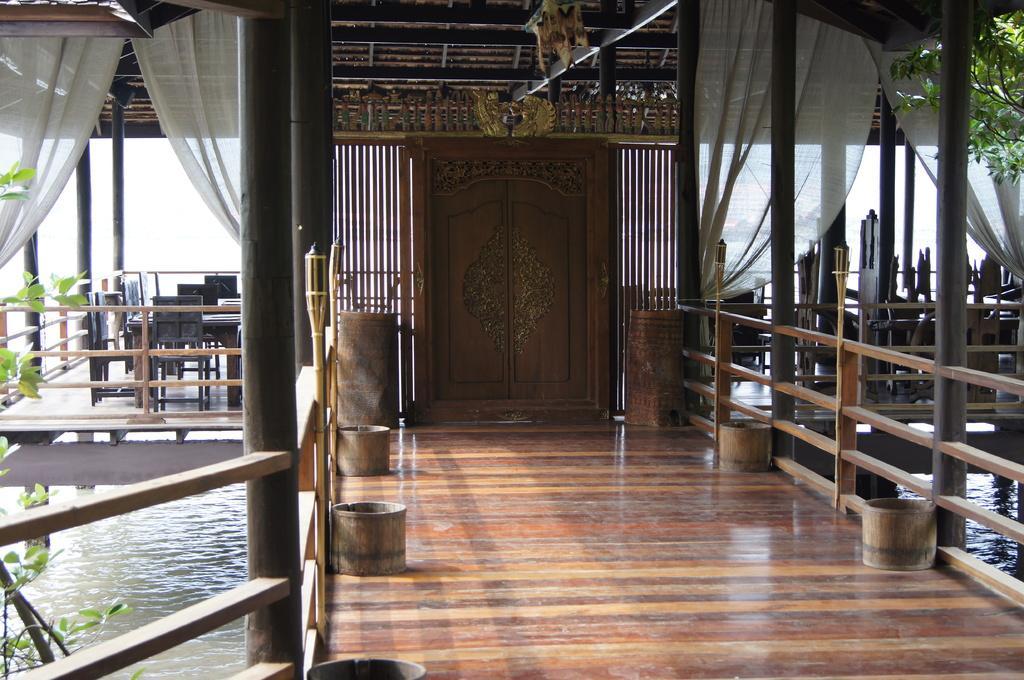In one or two sentences, can you explain what this image depicts? The picture consists of a wooden construction. In the foreground there are wooden pots, pillars, trees and curtains. In the center of the picture there is a door. In the background there are chairs and tables. At the bottom there is water. 